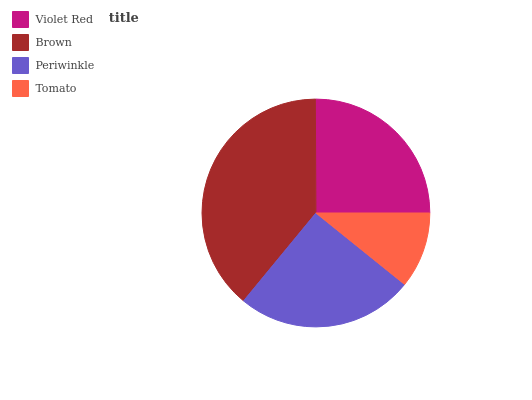Is Tomato the minimum?
Answer yes or no. Yes. Is Brown the maximum?
Answer yes or no. Yes. Is Periwinkle the minimum?
Answer yes or no. No. Is Periwinkle the maximum?
Answer yes or no. No. Is Brown greater than Periwinkle?
Answer yes or no. Yes. Is Periwinkle less than Brown?
Answer yes or no. Yes. Is Periwinkle greater than Brown?
Answer yes or no. No. Is Brown less than Periwinkle?
Answer yes or no. No. Is Periwinkle the high median?
Answer yes or no. Yes. Is Violet Red the low median?
Answer yes or no. Yes. Is Tomato the high median?
Answer yes or no. No. Is Periwinkle the low median?
Answer yes or no. No. 